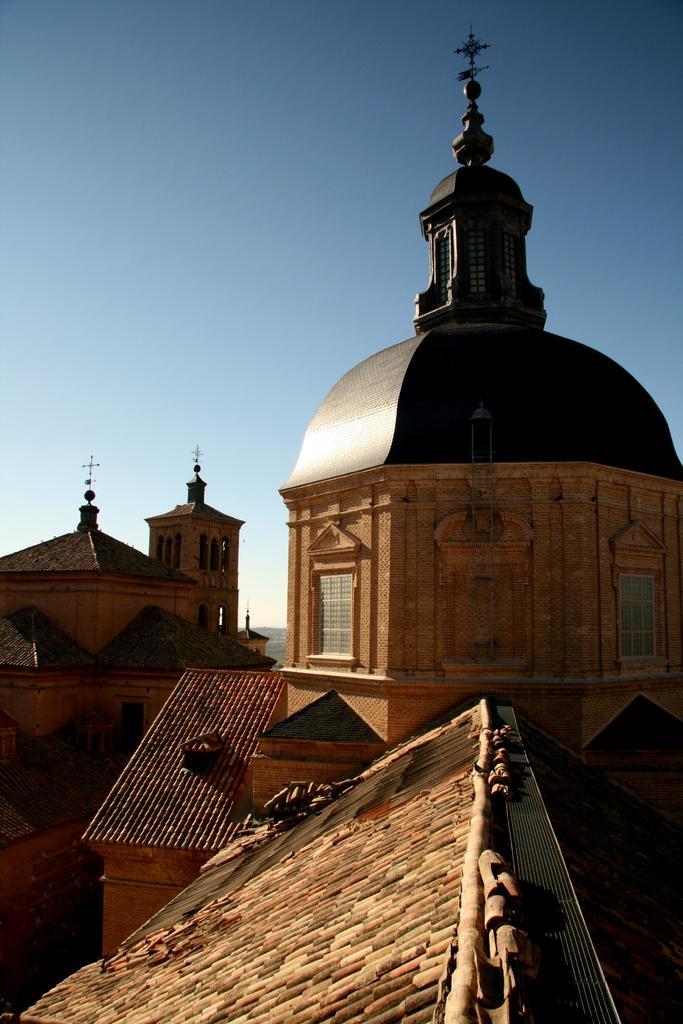Describe this image in one or two sentences. There are buildings with windows and arches. On top of the buildings there is cross. In the background there is sky. 